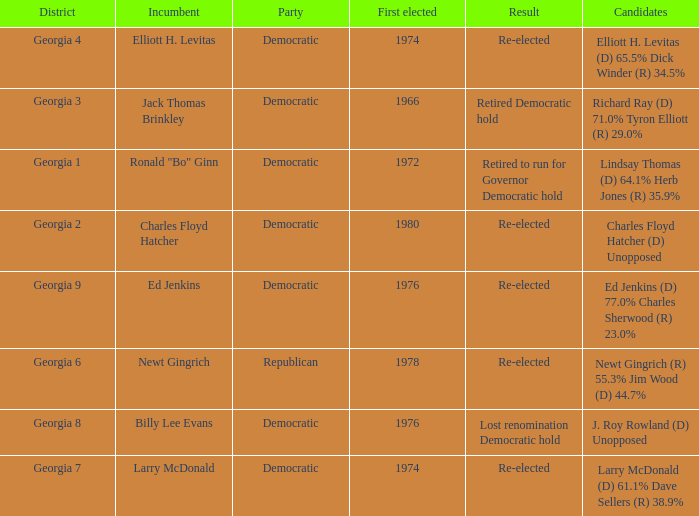Name the party for jack thomas brinkley Democratic. 